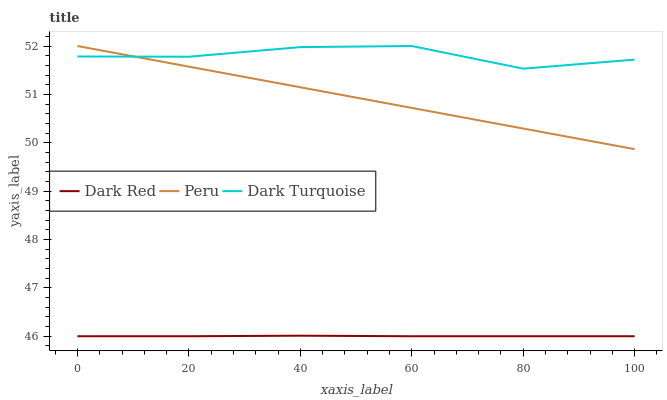Does Dark Red have the minimum area under the curve?
Answer yes or no. Yes. Does Dark Turquoise have the maximum area under the curve?
Answer yes or no. Yes. Does Peru have the minimum area under the curve?
Answer yes or no. No. Does Peru have the maximum area under the curve?
Answer yes or no. No. Is Peru the smoothest?
Answer yes or no. Yes. Is Dark Turquoise the roughest?
Answer yes or no. Yes. Is Dark Turquoise the smoothest?
Answer yes or no. No. Is Peru the roughest?
Answer yes or no. No. Does Dark Red have the lowest value?
Answer yes or no. Yes. Does Peru have the lowest value?
Answer yes or no. No. Does Dark Turquoise have the highest value?
Answer yes or no. Yes. Is Dark Red less than Dark Turquoise?
Answer yes or no. Yes. Is Peru greater than Dark Red?
Answer yes or no. Yes. Does Peru intersect Dark Turquoise?
Answer yes or no. Yes. Is Peru less than Dark Turquoise?
Answer yes or no. No. Is Peru greater than Dark Turquoise?
Answer yes or no. No. Does Dark Red intersect Dark Turquoise?
Answer yes or no. No. 